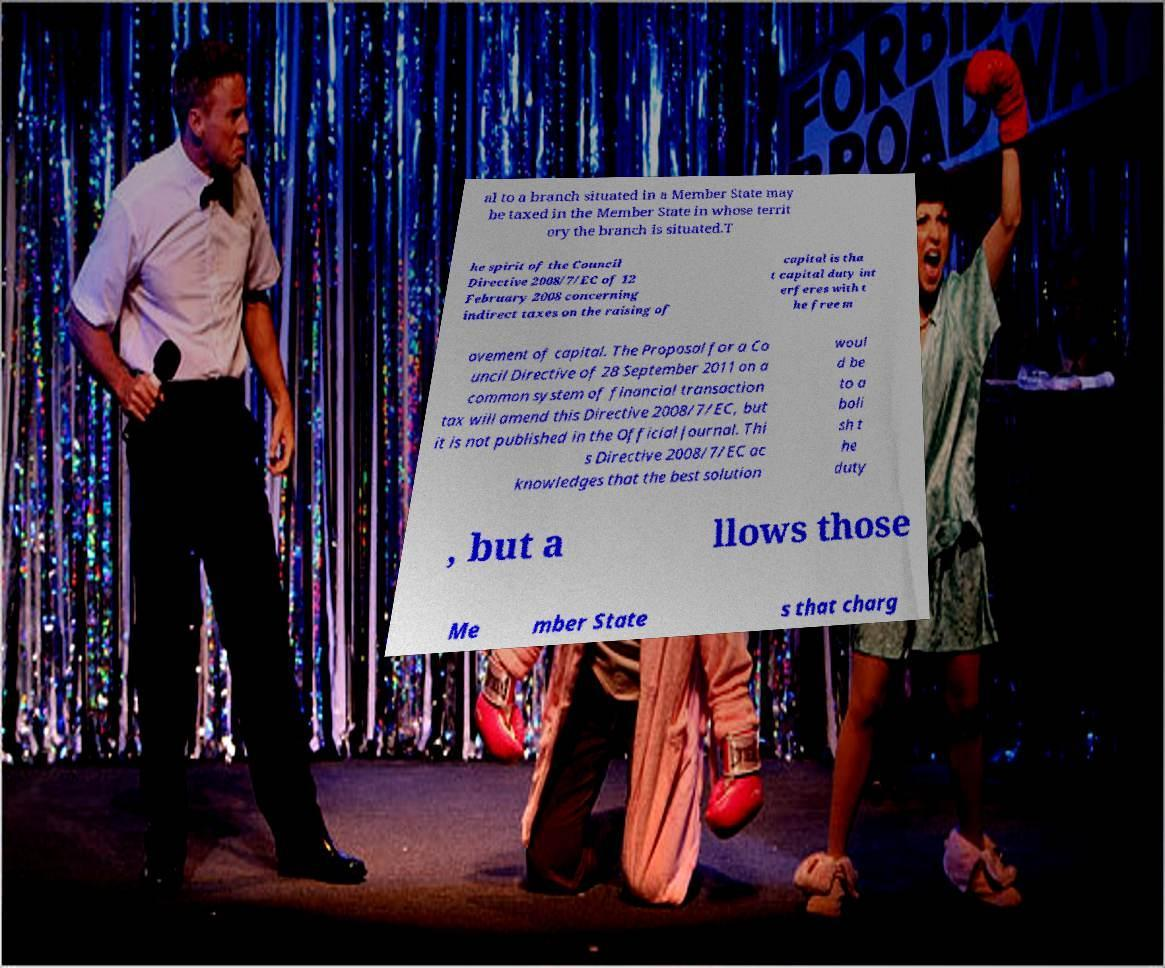Can you accurately transcribe the text from the provided image for me? al to a branch situated in a Member State may be taxed in the Member State in whose territ ory the branch is situated.T he spirit of the Council Directive 2008/7/EC of 12 February 2008 concerning indirect taxes on the raising of capital is tha t capital duty int erferes with t he free m ovement of capital. The Proposal for a Co uncil Directive of 28 September 2011 on a common system of financial transaction tax will amend this Directive 2008/7/EC, but it is not published in the Official Journal. Thi s Directive 2008/7/EC ac knowledges that the best solution woul d be to a boli sh t he duty , but a llows those Me mber State s that charg 